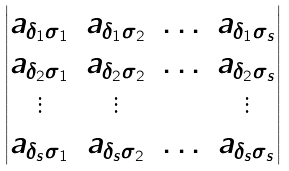Convert formula to latex. <formula><loc_0><loc_0><loc_500><loc_500>\begin{vmatrix} a _ { \delta _ { 1 } \sigma _ { 1 } } & a _ { \delta _ { 1 } \sigma _ { 2 } } & \hdots & a _ { \delta _ { 1 } \sigma _ { s } } \\ a _ { \delta _ { 2 } \sigma _ { 1 } } & a _ { \delta _ { 2 } \sigma _ { 2 } } & \hdots & a _ { \delta _ { 2 } \sigma _ { s } } \\ \vdots & \vdots & & \vdots \\ a _ { \delta _ { s } \sigma _ { 1 } } & a _ { \delta _ { s } \sigma _ { 2 } } & \hdots & a _ { \delta _ { s } \sigma _ { s } } \end{vmatrix}</formula> 